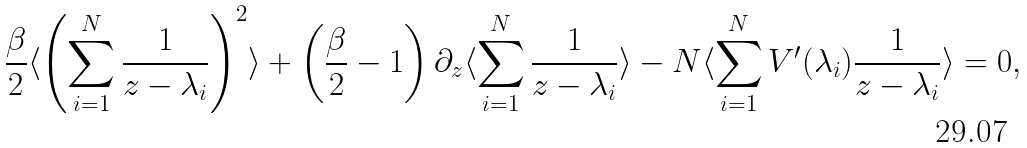Convert formula to latex. <formula><loc_0><loc_0><loc_500><loc_500>\frac { \beta } { 2 } \langle \left ( \sum _ { i = 1 } ^ { N } \frac { 1 } { z - \lambda _ { i } } \right ) ^ { 2 } \rangle + \left ( \frac { \beta } { 2 } - 1 \right ) \partial _ { z } \langle \sum _ { i = 1 } ^ { N } \frac { 1 } { z - \lambda _ { i } } \rangle - N \langle \sum _ { i = 1 } ^ { N } V ^ { \prime } ( \lambda _ { i } ) \frac { 1 } { z - \lambda _ { i } } \rangle = 0 ,</formula> 